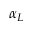Convert formula to latex. <formula><loc_0><loc_0><loc_500><loc_500>\alpha _ { L }</formula> 